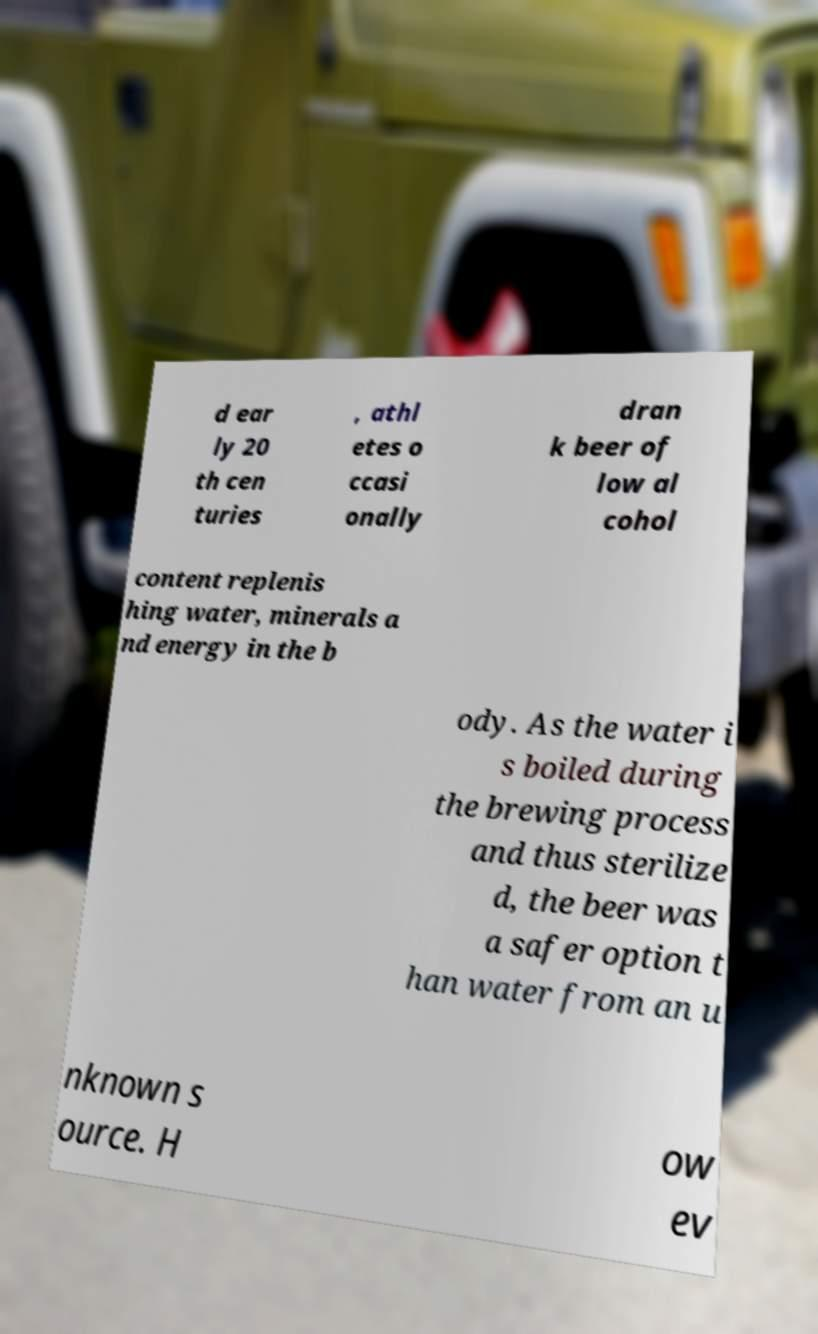What messages or text are displayed in this image? I need them in a readable, typed format. d ear ly 20 th cen turies , athl etes o ccasi onally dran k beer of low al cohol content replenis hing water, minerals a nd energy in the b ody. As the water i s boiled during the brewing process and thus sterilize d, the beer was a safer option t han water from an u nknown s ource. H ow ev 